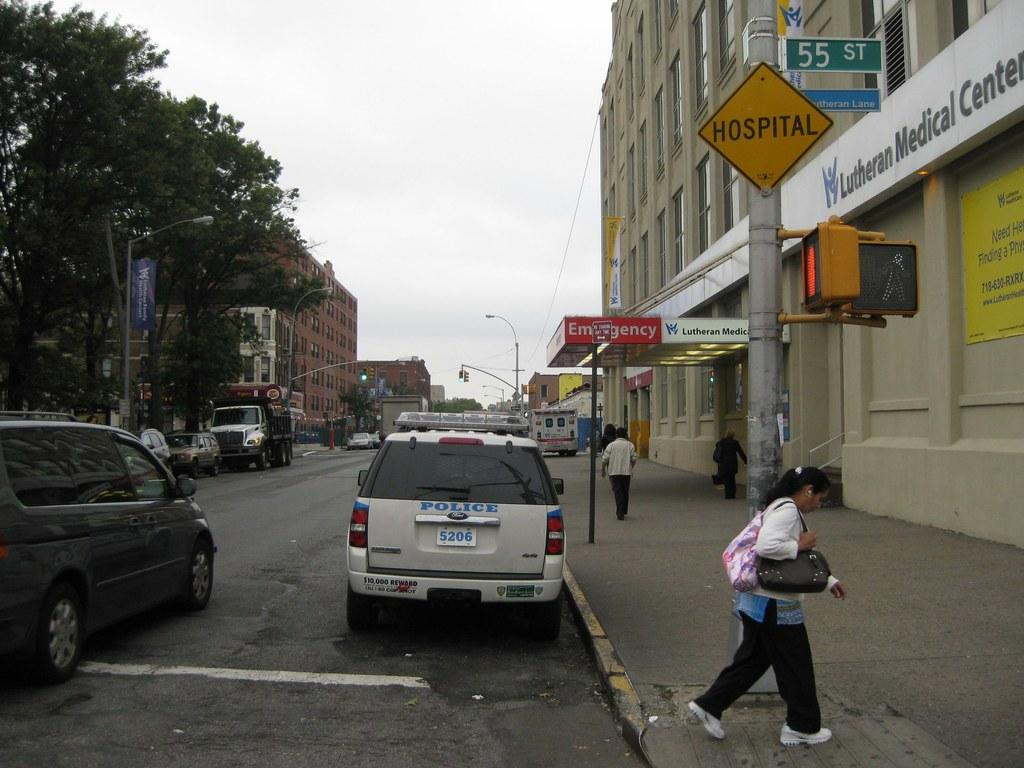<image>
Relay a brief, clear account of the picture shown. Woman walking in front of a sign which says HOSPITAL on it. 